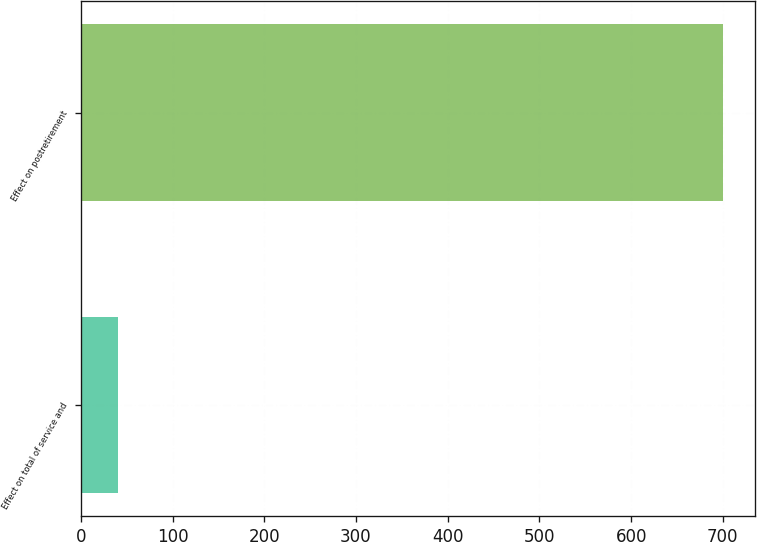Convert chart. <chart><loc_0><loc_0><loc_500><loc_500><bar_chart><fcel>Effect on total of service and<fcel>Effect on postretirement<nl><fcel>40<fcel>700<nl></chart> 